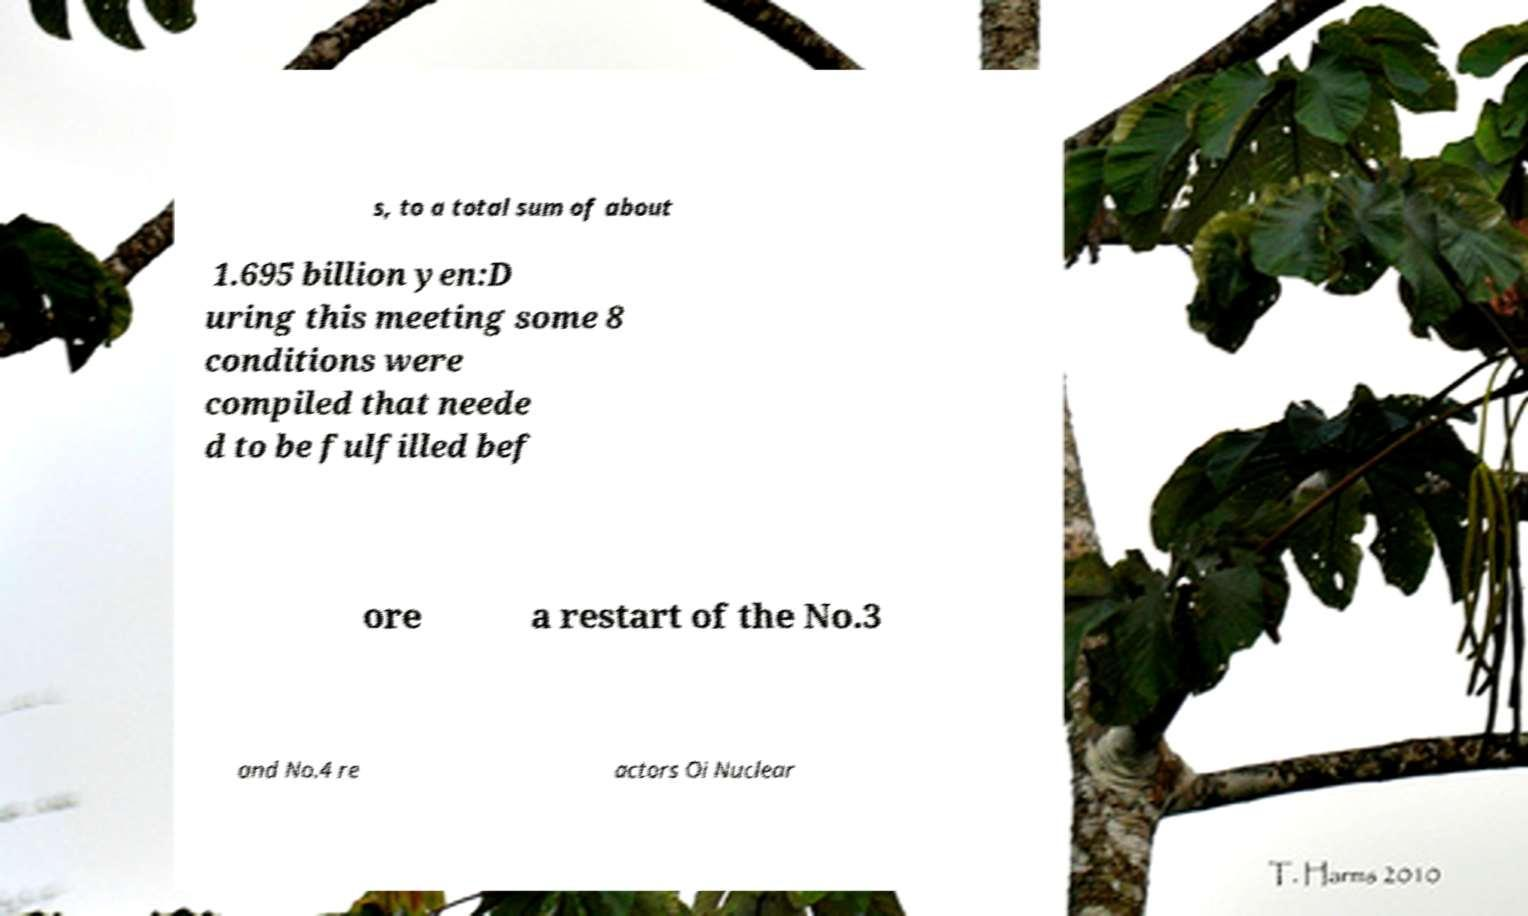I need the written content from this picture converted into text. Can you do that? s, to a total sum of about 1.695 billion yen:D uring this meeting some 8 conditions were compiled that neede d to be fulfilled bef ore a restart of the No.3 and No.4 re actors Oi Nuclear 